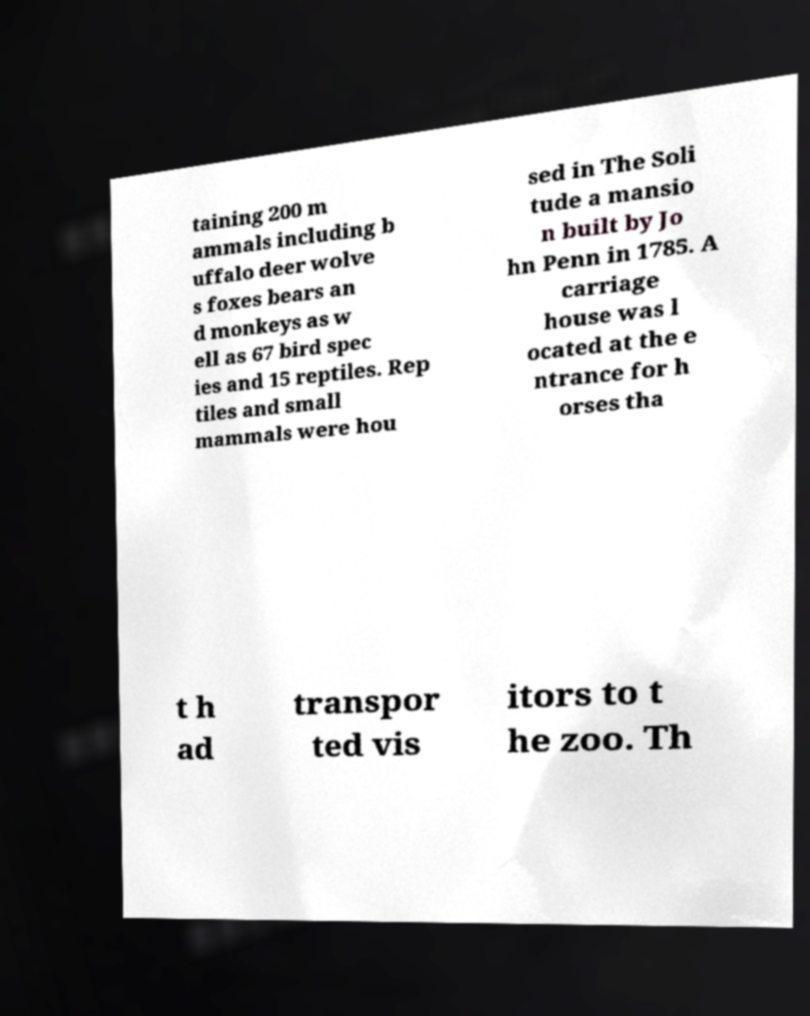Can you accurately transcribe the text from the provided image for me? taining 200 m ammals including b uffalo deer wolve s foxes bears an d monkeys as w ell as 67 bird spec ies and 15 reptiles. Rep tiles and small mammals were hou sed in The Soli tude a mansio n built by Jo hn Penn in 1785. A carriage house was l ocated at the e ntrance for h orses tha t h ad transpor ted vis itors to t he zoo. Th 